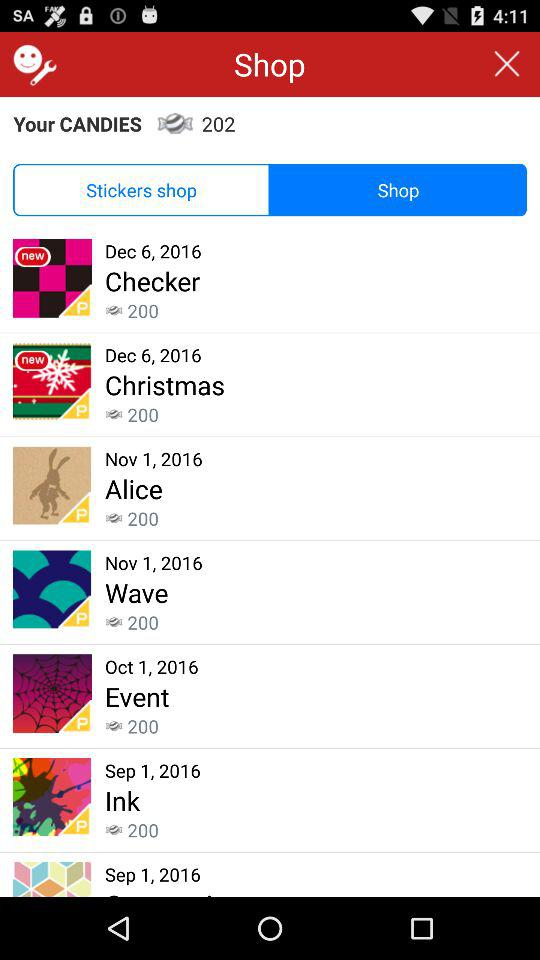What is the date for "Checker"? The date is December 6, 2016. 